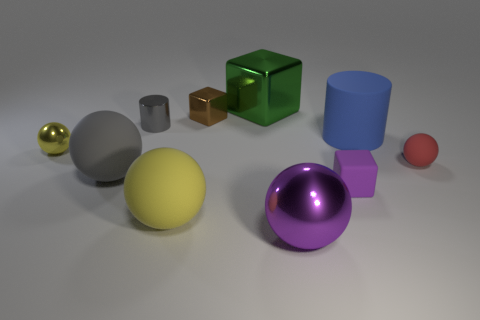What can you infer about the materials of the different objects? Based on their appearances, I can infer that the objects are made from distinct materials: the spheres and cylinder suggest metallic and rubber materials due to their sheen and color, the cube looks to be made of glass or a transparent plastic, and the blocks appear solid, possibly wood or plastic, indicated by their matte surfaces. 